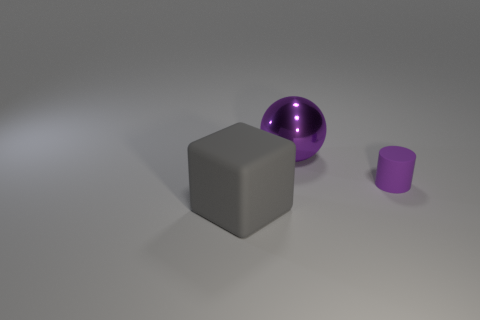Is there any other thing that has the same material as the big purple object?
Ensure brevity in your answer.  No. Are there any other purple spheres that have the same material as the ball?
Make the answer very short. No. The thing that is the same color as the tiny cylinder is what size?
Your answer should be very brief. Large. What number of objects are both behind the large gray cube and in front of the metallic thing?
Your answer should be very brief. 1. What is the purple thing that is right of the large purple sphere made of?
Provide a succinct answer. Rubber. What number of metal spheres are the same color as the tiny thing?
Your answer should be very brief. 1. There is a thing that is the same material as the cylinder; what size is it?
Your answer should be very brief. Large. What number of things are either blue rubber cylinders or big purple metal objects?
Provide a succinct answer. 1. There is a big thing on the right side of the large gray matte object; what is its color?
Ensure brevity in your answer.  Purple. How many things are either big things that are behind the large gray matte block or big things that are behind the big gray rubber cube?
Provide a short and direct response. 1. 